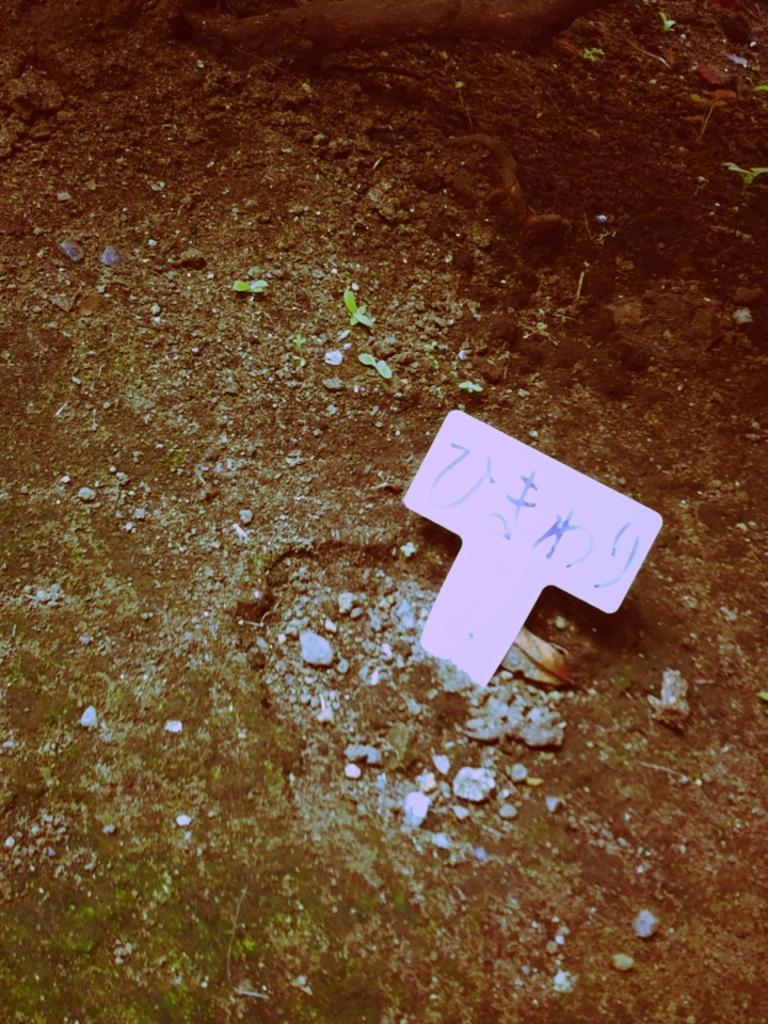What is written on in the image? There is text written on an object in the image. What type of vegetation can be seen in the image? There are small plants in the image. What can be found on the ground in the image? There are stones on the ground in the image. How many horses are present in the image? There are no horses present in the image. What type of stew is being prepared in the image? There is no stew being prepared in the image. 